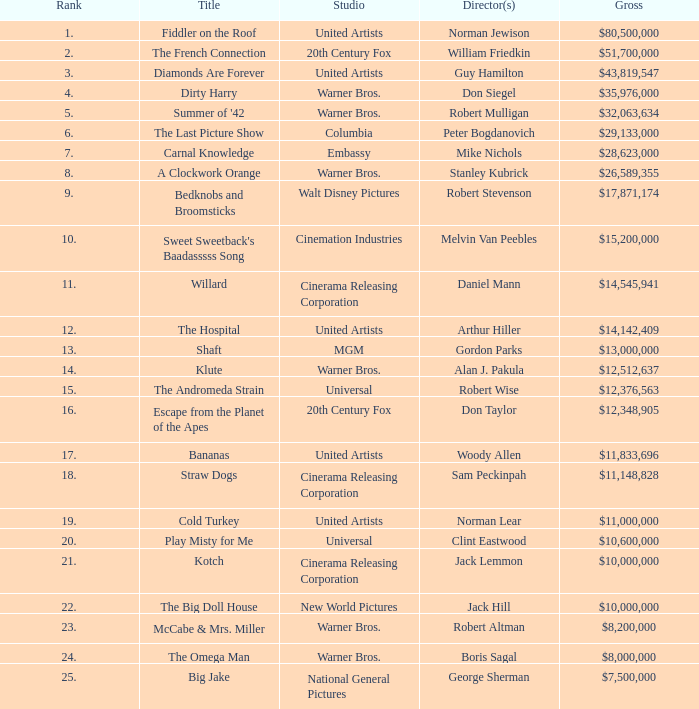What position has a total of $35,976,000? 4.0. Write the full table. {'header': ['Rank', 'Title', 'Studio', 'Director(s)', 'Gross'], 'rows': [['1.', 'Fiddler on the Roof', 'United Artists', 'Norman Jewison', '$80,500,000'], ['2.', 'The French Connection', '20th Century Fox', 'William Friedkin', '$51,700,000'], ['3.', 'Diamonds Are Forever', 'United Artists', 'Guy Hamilton', '$43,819,547'], ['4.', 'Dirty Harry', 'Warner Bros.', 'Don Siegel', '$35,976,000'], ['5.', "Summer of '42", 'Warner Bros.', 'Robert Mulligan', '$32,063,634'], ['6.', 'The Last Picture Show', 'Columbia', 'Peter Bogdanovich', '$29,133,000'], ['7.', 'Carnal Knowledge', 'Embassy', 'Mike Nichols', '$28,623,000'], ['8.', 'A Clockwork Orange', 'Warner Bros.', 'Stanley Kubrick', '$26,589,355'], ['9.', 'Bedknobs and Broomsticks', 'Walt Disney Pictures', 'Robert Stevenson', '$17,871,174'], ['10.', "Sweet Sweetback's Baadasssss Song", 'Cinemation Industries', 'Melvin Van Peebles', '$15,200,000'], ['11.', 'Willard', 'Cinerama Releasing Corporation', 'Daniel Mann', '$14,545,941'], ['12.', 'The Hospital', 'United Artists', 'Arthur Hiller', '$14,142,409'], ['13.', 'Shaft', 'MGM', 'Gordon Parks', '$13,000,000'], ['14.', 'Klute', 'Warner Bros.', 'Alan J. Pakula', '$12,512,637'], ['15.', 'The Andromeda Strain', 'Universal', 'Robert Wise', '$12,376,563'], ['16.', 'Escape from the Planet of the Apes', '20th Century Fox', 'Don Taylor', '$12,348,905'], ['17.', 'Bananas', 'United Artists', 'Woody Allen', '$11,833,696'], ['18.', 'Straw Dogs', 'Cinerama Releasing Corporation', 'Sam Peckinpah', '$11,148,828'], ['19.', 'Cold Turkey', 'United Artists', 'Norman Lear', '$11,000,000'], ['20.', 'Play Misty for Me', 'Universal', 'Clint Eastwood', '$10,600,000'], ['21.', 'Kotch', 'Cinerama Releasing Corporation', 'Jack Lemmon', '$10,000,000'], ['22.', 'The Big Doll House', 'New World Pictures', 'Jack Hill', '$10,000,000'], ['23.', 'McCabe & Mrs. Miller', 'Warner Bros.', 'Robert Altman', '$8,200,000'], ['24.', 'The Omega Man', 'Warner Bros.', 'Boris Sagal', '$8,000,000'], ['25.', 'Big Jake', 'National General Pictures', 'George Sherman', '$7,500,000']]} 